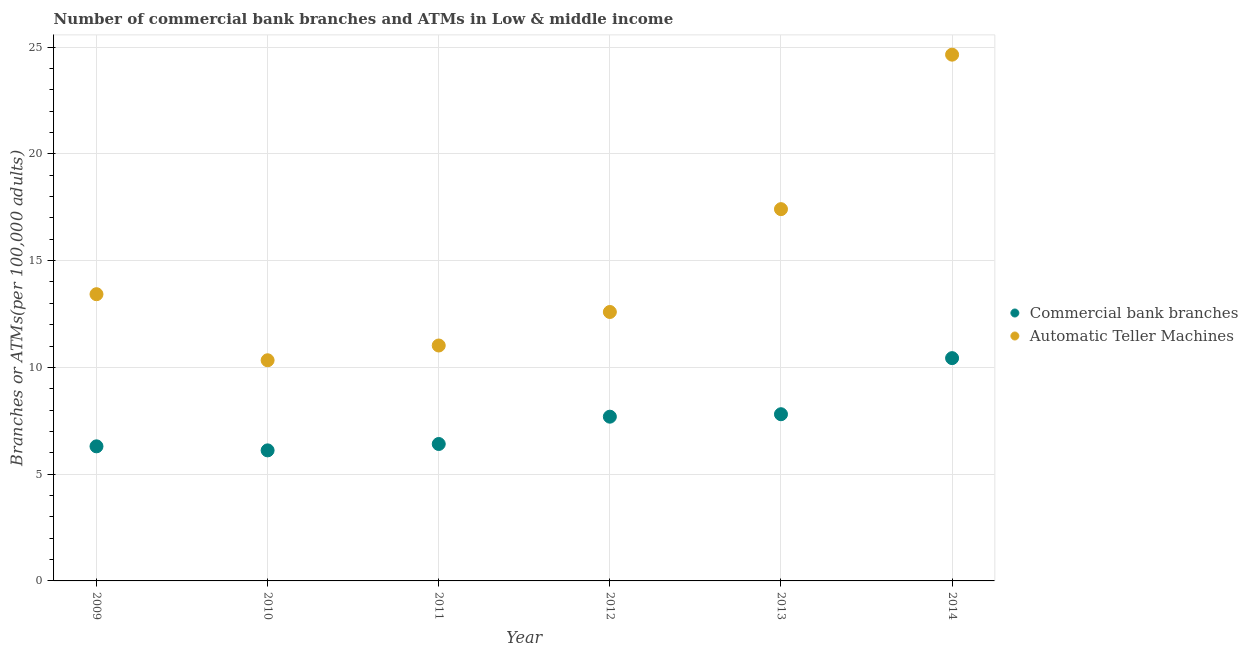How many different coloured dotlines are there?
Your answer should be very brief. 2. What is the number of commercal bank branches in 2011?
Ensure brevity in your answer.  6.41. Across all years, what is the maximum number of commercal bank branches?
Offer a terse response. 10.43. Across all years, what is the minimum number of atms?
Your answer should be compact. 10.33. In which year was the number of atms minimum?
Offer a terse response. 2010. What is the total number of commercal bank branches in the graph?
Provide a short and direct response. 44.76. What is the difference between the number of atms in 2010 and that in 2012?
Provide a succinct answer. -2.26. What is the difference between the number of commercal bank branches in 2010 and the number of atms in 2013?
Your answer should be compact. -11.3. What is the average number of commercal bank branches per year?
Provide a succinct answer. 7.46. In the year 2010, what is the difference between the number of atms and number of commercal bank branches?
Keep it short and to the point. 4.22. What is the ratio of the number of commercal bank branches in 2011 to that in 2014?
Provide a short and direct response. 0.61. Is the number of commercal bank branches in 2011 less than that in 2014?
Keep it short and to the point. Yes. Is the difference between the number of commercal bank branches in 2009 and 2012 greater than the difference between the number of atms in 2009 and 2012?
Provide a short and direct response. No. What is the difference between the highest and the second highest number of commercal bank branches?
Your response must be concise. 2.63. What is the difference between the highest and the lowest number of commercal bank branches?
Provide a succinct answer. 4.32. Is the sum of the number of commercal bank branches in 2012 and 2014 greater than the maximum number of atms across all years?
Offer a very short reply. No. Does the number of commercal bank branches monotonically increase over the years?
Make the answer very short. No. Is the number of commercal bank branches strictly less than the number of atms over the years?
Your answer should be very brief. Yes. How many years are there in the graph?
Offer a terse response. 6. Are the values on the major ticks of Y-axis written in scientific E-notation?
Offer a terse response. No. Does the graph contain any zero values?
Offer a terse response. No. Does the graph contain grids?
Keep it short and to the point. Yes. How are the legend labels stacked?
Offer a terse response. Vertical. What is the title of the graph?
Offer a terse response. Number of commercial bank branches and ATMs in Low & middle income. What is the label or title of the Y-axis?
Your response must be concise. Branches or ATMs(per 100,0 adults). What is the Branches or ATMs(per 100,000 adults) of Commercial bank branches in 2009?
Your answer should be very brief. 6.3. What is the Branches or ATMs(per 100,000 adults) in Automatic Teller Machines in 2009?
Your answer should be very brief. 13.43. What is the Branches or ATMs(per 100,000 adults) of Commercial bank branches in 2010?
Offer a very short reply. 6.11. What is the Branches or ATMs(per 100,000 adults) in Automatic Teller Machines in 2010?
Your answer should be very brief. 10.33. What is the Branches or ATMs(per 100,000 adults) in Commercial bank branches in 2011?
Offer a terse response. 6.41. What is the Branches or ATMs(per 100,000 adults) in Automatic Teller Machines in 2011?
Provide a succinct answer. 11.03. What is the Branches or ATMs(per 100,000 adults) in Commercial bank branches in 2012?
Provide a succinct answer. 7.69. What is the Branches or ATMs(per 100,000 adults) of Automatic Teller Machines in 2012?
Keep it short and to the point. 12.59. What is the Branches or ATMs(per 100,000 adults) of Commercial bank branches in 2013?
Your answer should be very brief. 7.81. What is the Branches or ATMs(per 100,000 adults) of Automatic Teller Machines in 2013?
Your response must be concise. 17.41. What is the Branches or ATMs(per 100,000 adults) in Commercial bank branches in 2014?
Your answer should be compact. 10.43. What is the Branches or ATMs(per 100,000 adults) in Automatic Teller Machines in 2014?
Ensure brevity in your answer.  24.65. Across all years, what is the maximum Branches or ATMs(per 100,000 adults) in Commercial bank branches?
Offer a very short reply. 10.43. Across all years, what is the maximum Branches or ATMs(per 100,000 adults) of Automatic Teller Machines?
Your answer should be very brief. 24.65. Across all years, what is the minimum Branches or ATMs(per 100,000 adults) in Commercial bank branches?
Offer a terse response. 6.11. Across all years, what is the minimum Branches or ATMs(per 100,000 adults) of Automatic Teller Machines?
Your answer should be compact. 10.33. What is the total Branches or ATMs(per 100,000 adults) of Commercial bank branches in the graph?
Keep it short and to the point. 44.76. What is the total Branches or ATMs(per 100,000 adults) of Automatic Teller Machines in the graph?
Your answer should be very brief. 89.44. What is the difference between the Branches or ATMs(per 100,000 adults) in Commercial bank branches in 2009 and that in 2010?
Your response must be concise. 0.19. What is the difference between the Branches or ATMs(per 100,000 adults) of Automatic Teller Machines in 2009 and that in 2010?
Keep it short and to the point. 3.09. What is the difference between the Branches or ATMs(per 100,000 adults) in Commercial bank branches in 2009 and that in 2011?
Make the answer very short. -0.11. What is the difference between the Branches or ATMs(per 100,000 adults) of Automatic Teller Machines in 2009 and that in 2011?
Your response must be concise. 2.4. What is the difference between the Branches or ATMs(per 100,000 adults) in Commercial bank branches in 2009 and that in 2012?
Provide a succinct answer. -1.39. What is the difference between the Branches or ATMs(per 100,000 adults) of Automatic Teller Machines in 2009 and that in 2012?
Your response must be concise. 0.83. What is the difference between the Branches or ATMs(per 100,000 adults) in Commercial bank branches in 2009 and that in 2013?
Make the answer very short. -1.5. What is the difference between the Branches or ATMs(per 100,000 adults) of Automatic Teller Machines in 2009 and that in 2013?
Give a very brief answer. -3.98. What is the difference between the Branches or ATMs(per 100,000 adults) of Commercial bank branches in 2009 and that in 2014?
Offer a terse response. -4.13. What is the difference between the Branches or ATMs(per 100,000 adults) of Automatic Teller Machines in 2009 and that in 2014?
Provide a short and direct response. -11.22. What is the difference between the Branches or ATMs(per 100,000 adults) of Commercial bank branches in 2010 and that in 2011?
Your answer should be compact. -0.3. What is the difference between the Branches or ATMs(per 100,000 adults) of Automatic Teller Machines in 2010 and that in 2011?
Offer a terse response. -0.69. What is the difference between the Branches or ATMs(per 100,000 adults) in Commercial bank branches in 2010 and that in 2012?
Keep it short and to the point. -1.58. What is the difference between the Branches or ATMs(per 100,000 adults) in Automatic Teller Machines in 2010 and that in 2012?
Ensure brevity in your answer.  -2.26. What is the difference between the Branches or ATMs(per 100,000 adults) of Commercial bank branches in 2010 and that in 2013?
Provide a succinct answer. -1.69. What is the difference between the Branches or ATMs(per 100,000 adults) in Automatic Teller Machines in 2010 and that in 2013?
Ensure brevity in your answer.  -7.08. What is the difference between the Branches or ATMs(per 100,000 adults) in Commercial bank branches in 2010 and that in 2014?
Provide a short and direct response. -4.32. What is the difference between the Branches or ATMs(per 100,000 adults) of Automatic Teller Machines in 2010 and that in 2014?
Your answer should be compact. -14.31. What is the difference between the Branches or ATMs(per 100,000 adults) in Commercial bank branches in 2011 and that in 2012?
Your answer should be compact. -1.28. What is the difference between the Branches or ATMs(per 100,000 adults) in Automatic Teller Machines in 2011 and that in 2012?
Give a very brief answer. -1.57. What is the difference between the Branches or ATMs(per 100,000 adults) in Commercial bank branches in 2011 and that in 2013?
Offer a terse response. -1.39. What is the difference between the Branches or ATMs(per 100,000 adults) of Automatic Teller Machines in 2011 and that in 2013?
Make the answer very short. -6.39. What is the difference between the Branches or ATMs(per 100,000 adults) of Commercial bank branches in 2011 and that in 2014?
Make the answer very short. -4.02. What is the difference between the Branches or ATMs(per 100,000 adults) in Automatic Teller Machines in 2011 and that in 2014?
Give a very brief answer. -13.62. What is the difference between the Branches or ATMs(per 100,000 adults) in Commercial bank branches in 2012 and that in 2013?
Offer a very short reply. -0.12. What is the difference between the Branches or ATMs(per 100,000 adults) of Automatic Teller Machines in 2012 and that in 2013?
Provide a succinct answer. -4.82. What is the difference between the Branches or ATMs(per 100,000 adults) in Commercial bank branches in 2012 and that in 2014?
Offer a very short reply. -2.74. What is the difference between the Branches or ATMs(per 100,000 adults) in Automatic Teller Machines in 2012 and that in 2014?
Your response must be concise. -12.05. What is the difference between the Branches or ATMs(per 100,000 adults) in Commercial bank branches in 2013 and that in 2014?
Give a very brief answer. -2.63. What is the difference between the Branches or ATMs(per 100,000 adults) in Automatic Teller Machines in 2013 and that in 2014?
Provide a short and direct response. -7.23. What is the difference between the Branches or ATMs(per 100,000 adults) of Commercial bank branches in 2009 and the Branches or ATMs(per 100,000 adults) of Automatic Teller Machines in 2010?
Keep it short and to the point. -4.03. What is the difference between the Branches or ATMs(per 100,000 adults) of Commercial bank branches in 2009 and the Branches or ATMs(per 100,000 adults) of Automatic Teller Machines in 2011?
Keep it short and to the point. -4.72. What is the difference between the Branches or ATMs(per 100,000 adults) of Commercial bank branches in 2009 and the Branches or ATMs(per 100,000 adults) of Automatic Teller Machines in 2012?
Your answer should be compact. -6.29. What is the difference between the Branches or ATMs(per 100,000 adults) of Commercial bank branches in 2009 and the Branches or ATMs(per 100,000 adults) of Automatic Teller Machines in 2013?
Your answer should be very brief. -11.11. What is the difference between the Branches or ATMs(per 100,000 adults) of Commercial bank branches in 2009 and the Branches or ATMs(per 100,000 adults) of Automatic Teller Machines in 2014?
Provide a short and direct response. -18.34. What is the difference between the Branches or ATMs(per 100,000 adults) in Commercial bank branches in 2010 and the Branches or ATMs(per 100,000 adults) in Automatic Teller Machines in 2011?
Offer a terse response. -4.91. What is the difference between the Branches or ATMs(per 100,000 adults) in Commercial bank branches in 2010 and the Branches or ATMs(per 100,000 adults) in Automatic Teller Machines in 2012?
Make the answer very short. -6.48. What is the difference between the Branches or ATMs(per 100,000 adults) in Commercial bank branches in 2010 and the Branches or ATMs(per 100,000 adults) in Automatic Teller Machines in 2013?
Make the answer very short. -11.3. What is the difference between the Branches or ATMs(per 100,000 adults) in Commercial bank branches in 2010 and the Branches or ATMs(per 100,000 adults) in Automatic Teller Machines in 2014?
Your response must be concise. -18.53. What is the difference between the Branches or ATMs(per 100,000 adults) in Commercial bank branches in 2011 and the Branches or ATMs(per 100,000 adults) in Automatic Teller Machines in 2012?
Ensure brevity in your answer.  -6.18. What is the difference between the Branches or ATMs(per 100,000 adults) of Commercial bank branches in 2011 and the Branches or ATMs(per 100,000 adults) of Automatic Teller Machines in 2013?
Your response must be concise. -11. What is the difference between the Branches or ATMs(per 100,000 adults) in Commercial bank branches in 2011 and the Branches or ATMs(per 100,000 adults) in Automatic Teller Machines in 2014?
Keep it short and to the point. -18.23. What is the difference between the Branches or ATMs(per 100,000 adults) of Commercial bank branches in 2012 and the Branches or ATMs(per 100,000 adults) of Automatic Teller Machines in 2013?
Offer a very short reply. -9.72. What is the difference between the Branches or ATMs(per 100,000 adults) of Commercial bank branches in 2012 and the Branches or ATMs(per 100,000 adults) of Automatic Teller Machines in 2014?
Offer a terse response. -16.95. What is the difference between the Branches or ATMs(per 100,000 adults) in Commercial bank branches in 2013 and the Branches or ATMs(per 100,000 adults) in Automatic Teller Machines in 2014?
Provide a short and direct response. -16.84. What is the average Branches or ATMs(per 100,000 adults) of Commercial bank branches per year?
Your answer should be compact. 7.46. What is the average Branches or ATMs(per 100,000 adults) in Automatic Teller Machines per year?
Your answer should be very brief. 14.91. In the year 2009, what is the difference between the Branches or ATMs(per 100,000 adults) of Commercial bank branches and Branches or ATMs(per 100,000 adults) of Automatic Teller Machines?
Make the answer very short. -7.12. In the year 2010, what is the difference between the Branches or ATMs(per 100,000 adults) of Commercial bank branches and Branches or ATMs(per 100,000 adults) of Automatic Teller Machines?
Offer a very short reply. -4.22. In the year 2011, what is the difference between the Branches or ATMs(per 100,000 adults) in Commercial bank branches and Branches or ATMs(per 100,000 adults) in Automatic Teller Machines?
Give a very brief answer. -4.61. In the year 2012, what is the difference between the Branches or ATMs(per 100,000 adults) in Commercial bank branches and Branches or ATMs(per 100,000 adults) in Automatic Teller Machines?
Your answer should be compact. -4.9. In the year 2013, what is the difference between the Branches or ATMs(per 100,000 adults) in Commercial bank branches and Branches or ATMs(per 100,000 adults) in Automatic Teller Machines?
Keep it short and to the point. -9.6. In the year 2014, what is the difference between the Branches or ATMs(per 100,000 adults) of Commercial bank branches and Branches or ATMs(per 100,000 adults) of Automatic Teller Machines?
Offer a terse response. -14.21. What is the ratio of the Branches or ATMs(per 100,000 adults) in Commercial bank branches in 2009 to that in 2010?
Your answer should be compact. 1.03. What is the ratio of the Branches or ATMs(per 100,000 adults) in Automatic Teller Machines in 2009 to that in 2010?
Offer a very short reply. 1.3. What is the ratio of the Branches or ATMs(per 100,000 adults) in Commercial bank branches in 2009 to that in 2011?
Your response must be concise. 0.98. What is the ratio of the Branches or ATMs(per 100,000 adults) of Automatic Teller Machines in 2009 to that in 2011?
Ensure brevity in your answer.  1.22. What is the ratio of the Branches or ATMs(per 100,000 adults) in Commercial bank branches in 2009 to that in 2012?
Give a very brief answer. 0.82. What is the ratio of the Branches or ATMs(per 100,000 adults) in Automatic Teller Machines in 2009 to that in 2012?
Keep it short and to the point. 1.07. What is the ratio of the Branches or ATMs(per 100,000 adults) in Commercial bank branches in 2009 to that in 2013?
Give a very brief answer. 0.81. What is the ratio of the Branches or ATMs(per 100,000 adults) of Automatic Teller Machines in 2009 to that in 2013?
Offer a terse response. 0.77. What is the ratio of the Branches or ATMs(per 100,000 adults) in Commercial bank branches in 2009 to that in 2014?
Ensure brevity in your answer.  0.6. What is the ratio of the Branches or ATMs(per 100,000 adults) in Automatic Teller Machines in 2009 to that in 2014?
Offer a terse response. 0.54. What is the ratio of the Branches or ATMs(per 100,000 adults) of Commercial bank branches in 2010 to that in 2011?
Make the answer very short. 0.95. What is the ratio of the Branches or ATMs(per 100,000 adults) in Automatic Teller Machines in 2010 to that in 2011?
Offer a very short reply. 0.94. What is the ratio of the Branches or ATMs(per 100,000 adults) of Commercial bank branches in 2010 to that in 2012?
Make the answer very short. 0.79. What is the ratio of the Branches or ATMs(per 100,000 adults) of Automatic Teller Machines in 2010 to that in 2012?
Ensure brevity in your answer.  0.82. What is the ratio of the Branches or ATMs(per 100,000 adults) in Commercial bank branches in 2010 to that in 2013?
Keep it short and to the point. 0.78. What is the ratio of the Branches or ATMs(per 100,000 adults) of Automatic Teller Machines in 2010 to that in 2013?
Offer a terse response. 0.59. What is the ratio of the Branches or ATMs(per 100,000 adults) of Commercial bank branches in 2010 to that in 2014?
Your answer should be compact. 0.59. What is the ratio of the Branches or ATMs(per 100,000 adults) in Automatic Teller Machines in 2010 to that in 2014?
Your answer should be very brief. 0.42. What is the ratio of the Branches or ATMs(per 100,000 adults) of Commercial bank branches in 2011 to that in 2012?
Make the answer very short. 0.83. What is the ratio of the Branches or ATMs(per 100,000 adults) in Automatic Teller Machines in 2011 to that in 2012?
Your answer should be very brief. 0.88. What is the ratio of the Branches or ATMs(per 100,000 adults) in Commercial bank branches in 2011 to that in 2013?
Keep it short and to the point. 0.82. What is the ratio of the Branches or ATMs(per 100,000 adults) in Automatic Teller Machines in 2011 to that in 2013?
Keep it short and to the point. 0.63. What is the ratio of the Branches or ATMs(per 100,000 adults) of Commercial bank branches in 2011 to that in 2014?
Ensure brevity in your answer.  0.61. What is the ratio of the Branches or ATMs(per 100,000 adults) in Automatic Teller Machines in 2011 to that in 2014?
Keep it short and to the point. 0.45. What is the ratio of the Branches or ATMs(per 100,000 adults) in Commercial bank branches in 2012 to that in 2013?
Give a very brief answer. 0.99. What is the ratio of the Branches or ATMs(per 100,000 adults) in Automatic Teller Machines in 2012 to that in 2013?
Give a very brief answer. 0.72. What is the ratio of the Branches or ATMs(per 100,000 adults) in Commercial bank branches in 2012 to that in 2014?
Give a very brief answer. 0.74. What is the ratio of the Branches or ATMs(per 100,000 adults) of Automatic Teller Machines in 2012 to that in 2014?
Offer a very short reply. 0.51. What is the ratio of the Branches or ATMs(per 100,000 adults) of Commercial bank branches in 2013 to that in 2014?
Your answer should be compact. 0.75. What is the ratio of the Branches or ATMs(per 100,000 adults) of Automatic Teller Machines in 2013 to that in 2014?
Keep it short and to the point. 0.71. What is the difference between the highest and the second highest Branches or ATMs(per 100,000 adults) of Commercial bank branches?
Your answer should be very brief. 2.63. What is the difference between the highest and the second highest Branches or ATMs(per 100,000 adults) of Automatic Teller Machines?
Provide a short and direct response. 7.23. What is the difference between the highest and the lowest Branches or ATMs(per 100,000 adults) of Commercial bank branches?
Your answer should be compact. 4.32. What is the difference between the highest and the lowest Branches or ATMs(per 100,000 adults) in Automatic Teller Machines?
Ensure brevity in your answer.  14.31. 